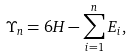Convert formula to latex. <formula><loc_0><loc_0><loc_500><loc_500>\Upsilon _ { n } = 6 H - \sum _ { i = 1 } ^ { n } E _ { i } ,</formula> 